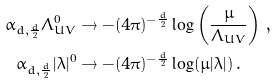<formula> <loc_0><loc_0><loc_500><loc_500>\alpha _ { d , \frac { d } { 2 } } \Lambda _ { U V } ^ { 0 } & \to - ( 4 \pi ) ^ { - \frac { d } { 2 } } \log \left ( \frac { \mu } { \Lambda _ { U V } } \right ) \, , \\ \alpha _ { d , \frac { d } { 2 } } | \lambda | ^ { 0 } & \to - ( 4 \pi ) ^ { - \frac { d } { 2 } } \log ( \mu | \lambda | ) \, .</formula> 